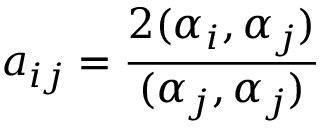<formula> <loc_0><loc_0><loc_500><loc_500>a _ { i j } = \frac { 2 ( \alpha _ { i } , \alpha _ { j } ) } { ( \alpha _ { j } , \alpha _ { j } ) }</formula> 